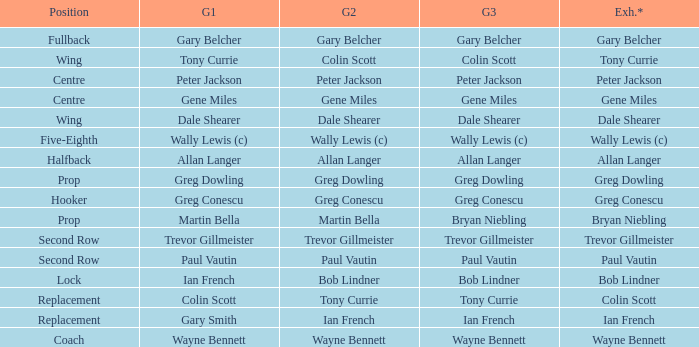What game 1 has halfback as a position? Allan Langer. 